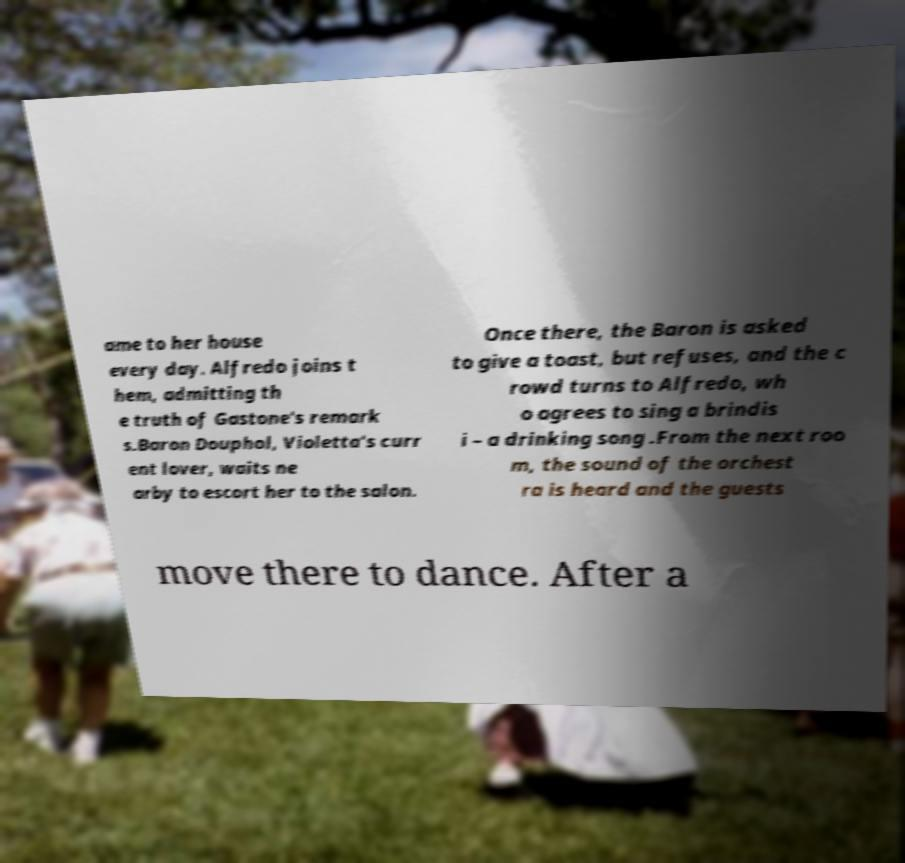For documentation purposes, I need the text within this image transcribed. Could you provide that? ame to her house every day. Alfredo joins t hem, admitting th e truth of Gastone's remark s.Baron Douphol, Violetta's curr ent lover, waits ne arby to escort her to the salon. Once there, the Baron is asked to give a toast, but refuses, and the c rowd turns to Alfredo, wh o agrees to sing a brindis i – a drinking song .From the next roo m, the sound of the orchest ra is heard and the guests move there to dance. After a 